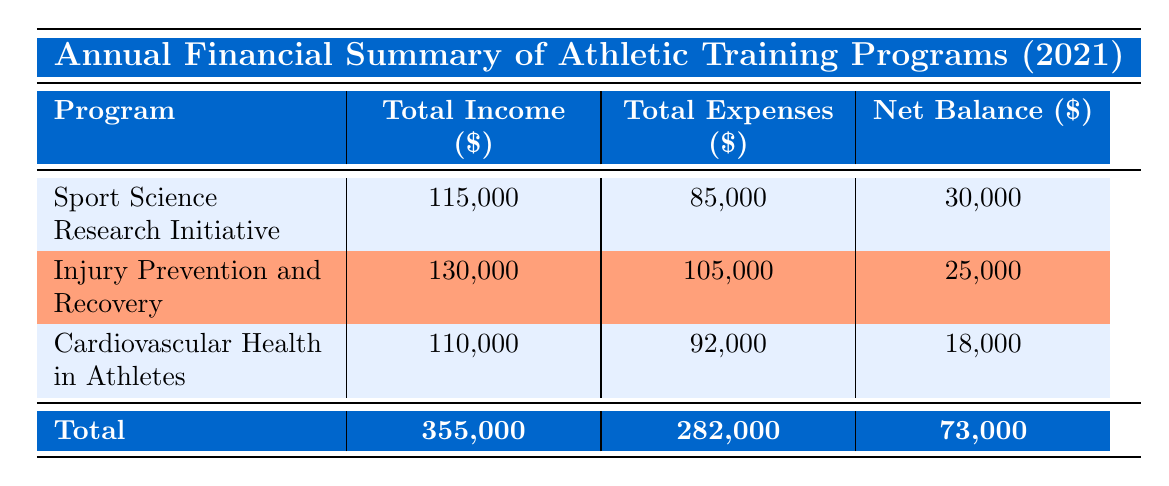What is the total income for the Injury Prevention and Recovery program? From the table, the total income for the Injury Prevention and Recovery program is given as 130,000.
Answer: 130,000 What are the total expenses for the Sport Science Research Initiative? The total expenses for the Sport Science Research Initiative are listed in the table as 85,000.
Answer: 85,000 Is the net balance for Cardiovascular Health in Athletes greater than 20,000? The net balance for Cardiovascular Health in Athletes is 18,000 according to the table, which is less than 20,000.
Answer: No What is the total income of all programs combined? Adding the total incomes from all programs: 115,000 + 130,000 + 110,000 = 355,000. So the total income is 355,000.
Answer: 355,000 Does the Injury Prevention and Recovery program have higher expenses than the Sport Science Research Initiative? The expenses for Injury Prevention and Recovery are 105,000, whereas the expenses for the Sport Science Research Initiative are 85,000. Since 105,000 is greater than 85,000, the statement is true.
Answer: Yes What is the average net balance of all programs? To find the average net balance, we add the net balances: 30,000 + 25,000 + 18,000 = 73,000 and then divide by the number of programs, which is 3. Thus, the average is 73,000 / 3 = 24,333.33.
Answer: 24,333.33 What is the total government grants received across all programs? The government grants for each program are: 30,000 (Sport Science) + 25,000 (Injury Prevention) + 35,000 (Cardiovascular Health) = 90,000. Thus, the total government grants are 90,000.
Answer: 90,000 Are the total expenses across all programs less than 300,000? The total expenses across all programs are 282,000 according to the table. Since 282,000 is less than 300,000, the statement is true.
Answer: Yes What is the difference in net balance between the Sport Science Research Initiative and Cardiovascular Health in Athletes? The net balance for Sport Science Research Initiative is 30,000 and for Cardiovascular Health in Athletes is 18,000. The difference is 30,000 - 18,000 = 12,000.
Answer: 12,000 